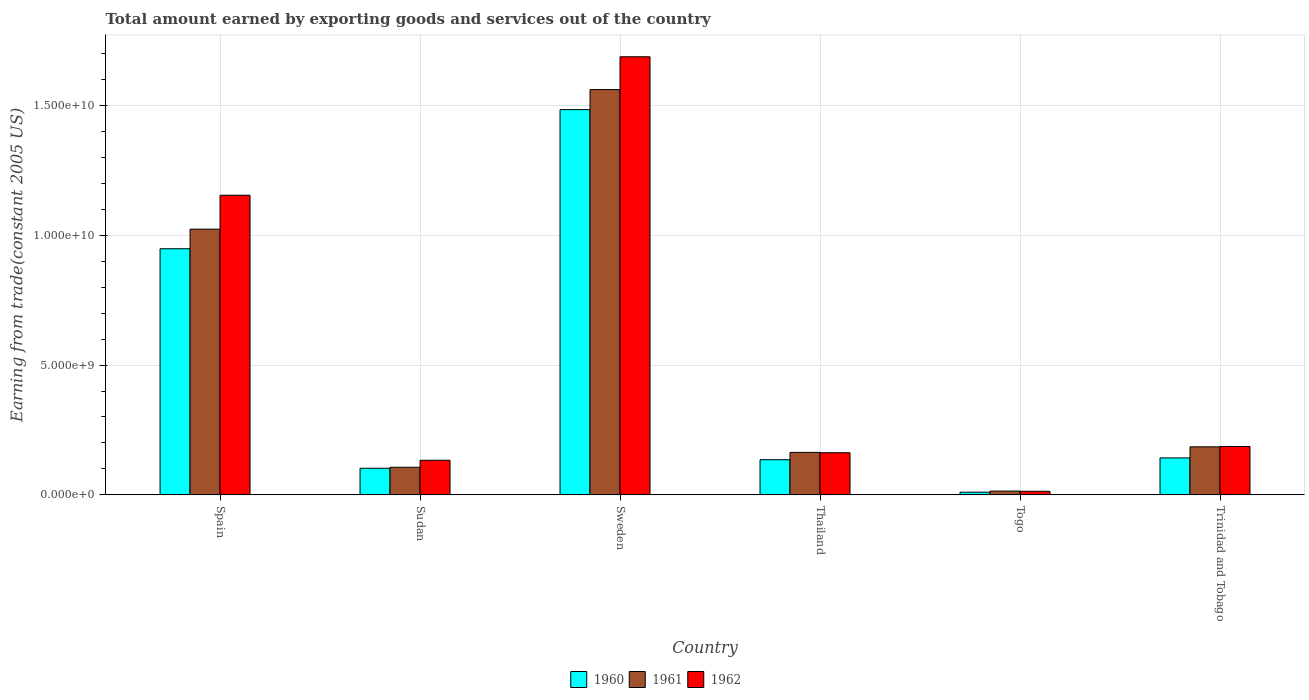How many groups of bars are there?
Your response must be concise. 6. How many bars are there on the 6th tick from the right?
Your answer should be very brief. 3. What is the label of the 5th group of bars from the left?
Provide a succinct answer. Togo. What is the total amount earned by exporting goods and services in 1960 in Sudan?
Offer a very short reply. 1.03e+09. Across all countries, what is the maximum total amount earned by exporting goods and services in 1960?
Your answer should be compact. 1.48e+1. Across all countries, what is the minimum total amount earned by exporting goods and services in 1962?
Your answer should be compact. 1.39e+08. In which country was the total amount earned by exporting goods and services in 1960 minimum?
Give a very brief answer. Togo. What is the total total amount earned by exporting goods and services in 1961 in the graph?
Your answer should be compact. 3.05e+1. What is the difference between the total amount earned by exporting goods and services in 1961 in Spain and that in Togo?
Give a very brief answer. 1.01e+1. What is the difference between the total amount earned by exporting goods and services in 1962 in Spain and the total amount earned by exporting goods and services in 1960 in Sweden?
Your answer should be very brief. -3.30e+09. What is the average total amount earned by exporting goods and services in 1961 per country?
Offer a terse response. 5.09e+09. What is the difference between the total amount earned by exporting goods and services of/in 1960 and total amount earned by exporting goods and services of/in 1961 in Trinidad and Tobago?
Ensure brevity in your answer.  -4.27e+08. What is the ratio of the total amount earned by exporting goods and services in 1962 in Sweden to that in Thailand?
Your answer should be very brief. 10.4. Is the total amount earned by exporting goods and services in 1962 in Togo less than that in Trinidad and Tobago?
Offer a terse response. Yes. What is the difference between the highest and the second highest total amount earned by exporting goods and services in 1962?
Your answer should be compact. -5.33e+09. What is the difference between the highest and the lowest total amount earned by exporting goods and services in 1960?
Ensure brevity in your answer.  1.47e+1. Is the sum of the total amount earned by exporting goods and services in 1962 in Sudan and Thailand greater than the maximum total amount earned by exporting goods and services in 1960 across all countries?
Your answer should be compact. No. What does the 1st bar from the left in Sweden represents?
Offer a terse response. 1960. What does the 1st bar from the right in Sudan represents?
Provide a succinct answer. 1962. Is it the case that in every country, the sum of the total amount earned by exporting goods and services in 1962 and total amount earned by exporting goods and services in 1961 is greater than the total amount earned by exporting goods and services in 1960?
Offer a very short reply. Yes. What is the difference between two consecutive major ticks on the Y-axis?
Keep it short and to the point. 5.00e+09. Does the graph contain any zero values?
Make the answer very short. No. Does the graph contain grids?
Keep it short and to the point. Yes. Where does the legend appear in the graph?
Your response must be concise. Bottom center. What is the title of the graph?
Your answer should be very brief. Total amount earned by exporting goods and services out of the country. What is the label or title of the Y-axis?
Offer a very short reply. Earning from trade(constant 2005 US). What is the Earning from trade(constant 2005 US) in 1960 in Spain?
Your answer should be compact. 9.48e+09. What is the Earning from trade(constant 2005 US) in 1961 in Spain?
Ensure brevity in your answer.  1.02e+1. What is the Earning from trade(constant 2005 US) in 1962 in Spain?
Give a very brief answer. 1.15e+1. What is the Earning from trade(constant 2005 US) in 1960 in Sudan?
Provide a short and direct response. 1.03e+09. What is the Earning from trade(constant 2005 US) in 1961 in Sudan?
Your response must be concise. 1.06e+09. What is the Earning from trade(constant 2005 US) in 1962 in Sudan?
Your answer should be very brief. 1.33e+09. What is the Earning from trade(constant 2005 US) of 1960 in Sweden?
Provide a succinct answer. 1.48e+1. What is the Earning from trade(constant 2005 US) of 1961 in Sweden?
Keep it short and to the point. 1.56e+1. What is the Earning from trade(constant 2005 US) in 1962 in Sweden?
Provide a short and direct response. 1.69e+1. What is the Earning from trade(constant 2005 US) in 1960 in Thailand?
Keep it short and to the point. 1.35e+09. What is the Earning from trade(constant 2005 US) in 1961 in Thailand?
Your answer should be compact. 1.64e+09. What is the Earning from trade(constant 2005 US) in 1962 in Thailand?
Provide a short and direct response. 1.62e+09. What is the Earning from trade(constant 2005 US) in 1960 in Togo?
Provide a succinct answer. 1.04e+08. What is the Earning from trade(constant 2005 US) in 1961 in Togo?
Provide a succinct answer. 1.46e+08. What is the Earning from trade(constant 2005 US) in 1962 in Togo?
Offer a very short reply. 1.39e+08. What is the Earning from trade(constant 2005 US) of 1960 in Trinidad and Tobago?
Give a very brief answer. 1.42e+09. What is the Earning from trade(constant 2005 US) of 1961 in Trinidad and Tobago?
Offer a terse response. 1.85e+09. What is the Earning from trade(constant 2005 US) of 1962 in Trinidad and Tobago?
Give a very brief answer. 1.86e+09. Across all countries, what is the maximum Earning from trade(constant 2005 US) of 1960?
Offer a very short reply. 1.48e+1. Across all countries, what is the maximum Earning from trade(constant 2005 US) in 1961?
Your response must be concise. 1.56e+1. Across all countries, what is the maximum Earning from trade(constant 2005 US) in 1962?
Your answer should be very brief. 1.69e+1. Across all countries, what is the minimum Earning from trade(constant 2005 US) of 1960?
Offer a terse response. 1.04e+08. Across all countries, what is the minimum Earning from trade(constant 2005 US) of 1961?
Offer a very short reply. 1.46e+08. Across all countries, what is the minimum Earning from trade(constant 2005 US) of 1962?
Provide a succinct answer. 1.39e+08. What is the total Earning from trade(constant 2005 US) in 1960 in the graph?
Offer a very short reply. 2.82e+1. What is the total Earning from trade(constant 2005 US) in 1961 in the graph?
Give a very brief answer. 3.05e+1. What is the total Earning from trade(constant 2005 US) in 1962 in the graph?
Give a very brief answer. 3.34e+1. What is the difference between the Earning from trade(constant 2005 US) of 1960 in Spain and that in Sudan?
Give a very brief answer. 8.45e+09. What is the difference between the Earning from trade(constant 2005 US) of 1961 in Spain and that in Sudan?
Keep it short and to the point. 9.17e+09. What is the difference between the Earning from trade(constant 2005 US) in 1962 in Spain and that in Sudan?
Your response must be concise. 1.02e+1. What is the difference between the Earning from trade(constant 2005 US) of 1960 in Spain and that in Sweden?
Your answer should be compact. -5.36e+09. What is the difference between the Earning from trade(constant 2005 US) of 1961 in Spain and that in Sweden?
Offer a terse response. -5.37e+09. What is the difference between the Earning from trade(constant 2005 US) of 1962 in Spain and that in Sweden?
Offer a very short reply. -5.33e+09. What is the difference between the Earning from trade(constant 2005 US) in 1960 in Spain and that in Thailand?
Make the answer very short. 8.12e+09. What is the difference between the Earning from trade(constant 2005 US) of 1961 in Spain and that in Thailand?
Ensure brevity in your answer.  8.59e+09. What is the difference between the Earning from trade(constant 2005 US) in 1962 in Spain and that in Thailand?
Make the answer very short. 9.92e+09. What is the difference between the Earning from trade(constant 2005 US) of 1960 in Spain and that in Togo?
Make the answer very short. 9.37e+09. What is the difference between the Earning from trade(constant 2005 US) of 1961 in Spain and that in Togo?
Make the answer very short. 1.01e+1. What is the difference between the Earning from trade(constant 2005 US) of 1962 in Spain and that in Togo?
Make the answer very short. 1.14e+1. What is the difference between the Earning from trade(constant 2005 US) of 1960 in Spain and that in Trinidad and Tobago?
Your response must be concise. 8.05e+09. What is the difference between the Earning from trade(constant 2005 US) in 1961 in Spain and that in Trinidad and Tobago?
Your answer should be very brief. 8.38e+09. What is the difference between the Earning from trade(constant 2005 US) of 1962 in Spain and that in Trinidad and Tobago?
Your answer should be compact. 9.67e+09. What is the difference between the Earning from trade(constant 2005 US) of 1960 in Sudan and that in Sweden?
Keep it short and to the point. -1.38e+1. What is the difference between the Earning from trade(constant 2005 US) in 1961 in Sudan and that in Sweden?
Offer a very short reply. -1.45e+1. What is the difference between the Earning from trade(constant 2005 US) of 1962 in Sudan and that in Sweden?
Give a very brief answer. -1.55e+1. What is the difference between the Earning from trade(constant 2005 US) of 1960 in Sudan and that in Thailand?
Make the answer very short. -3.29e+08. What is the difference between the Earning from trade(constant 2005 US) of 1961 in Sudan and that in Thailand?
Offer a terse response. -5.74e+08. What is the difference between the Earning from trade(constant 2005 US) in 1962 in Sudan and that in Thailand?
Your answer should be very brief. -2.89e+08. What is the difference between the Earning from trade(constant 2005 US) in 1960 in Sudan and that in Togo?
Keep it short and to the point. 9.22e+08. What is the difference between the Earning from trade(constant 2005 US) of 1961 in Sudan and that in Togo?
Your answer should be very brief. 9.17e+08. What is the difference between the Earning from trade(constant 2005 US) in 1962 in Sudan and that in Togo?
Your response must be concise. 1.19e+09. What is the difference between the Earning from trade(constant 2005 US) of 1960 in Sudan and that in Trinidad and Tobago?
Give a very brief answer. -3.98e+08. What is the difference between the Earning from trade(constant 2005 US) in 1961 in Sudan and that in Trinidad and Tobago?
Your answer should be compact. -7.87e+08. What is the difference between the Earning from trade(constant 2005 US) of 1962 in Sudan and that in Trinidad and Tobago?
Keep it short and to the point. -5.31e+08. What is the difference between the Earning from trade(constant 2005 US) of 1960 in Sweden and that in Thailand?
Provide a succinct answer. 1.35e+1. What is the difference between the Earning from trade(constant 2005 US) in 1961 in Sweden and that in Thailand?
Provide a short and direct response. 1.40e+1. What is the difference between the Earning from trade(constant 2005 US) in 1962 in Sweden and that in Thailand?
Ensure brevity in your answer.  1.52e+1. What is the difference between the Earning from trade(constant 2005 US) in 1960 in Sweden and that in Togo?
Give a very brief answer. 1.47e+1. What is the difference between the Earning from trade(constant 2005 US) of 1961 in Sweden and that in Togo?
Your answer should be compact. 1.55e+1. What is the difference between the Earning from trade(constant 2005 US) in 1962 in Sweden and that in Togo?
Offer a very short reply. 1.67e+1. What is the difference between the Earning from trade(constant 2005 US) of 1960 in Sweden and that in Trinidad and Tobago?
Offer a terse response. 1.34e+1. What is the difference between the Earning from trade(constant 2005 US) in 1961 in Sweden and that in Trinidad and Tobago?
Provide a succinct answer. 1.38e+1. What is the difference between the Earning from trade(constant 2005 US) in 1962 in Sweden and that in Trinidad and Tobago?
Offer a terse response. 1.50e+1. What is the difference between the Earning from trade(constant 2005 US) in 1960 in Thailand and that in Togo?
Your response must be concise. 1.25e+09. What is the difference between the Earning from trade(constant 2005 US) in 1961 in Thailand and that in Togo?
Give a very brief answer. 1.49e+09. What is the difference between the Earning from trade(constant 2005 US) of 1962 in Thailand and that in Togo?
Your answer should be compact. 1.48e+09. What is the difference between the Earning from trade(constant 2005 US) of 1960 in Thailand and that in Trinidad and Tobago?
Provide a succinct answer. -6.88e+07. What is the difference between the Earning from trade(constant 2005 US) in 1961 in Thailand and that in Trinidad and Tobago?
Offer a very short reply. -2.13e+08. What is the difference between the Earning from trade(constant 2005 US) in 1962 in Thailand and that in Trinidad and Tobago?
Provide a succinct answer. -2.41e+08. What is the difference between the Earning from trade(constant 2005 US) of 1960 in Togo and that in Trinidad and Tobago?
Ensure brevity in your answer.  -1.32e+09. What is the difference between the Earning from trade(constant 2005 US) of 1961 in Togo and that in Trinidad and Tobago?
Your answer should be very brief. -1.70e+09. What is the difference between the Earning from trade(constant 2005 US) in 1962 in Togo and that in Trinidad and Tobago?
Your answer should be compact. -1.73e+09. What is the difference between the Earning from trade(constant 2005 US) in 1960 in Spain and the Earning from trade(constant 2005 US) in 1961 in Sudan?
Keep it short and to the point. 8.41e+09. What is the difference between the Earning from trade(constant 2005 US) in 1960 in Spain and the Earning from trade(constant 2005 US) in 1962 in Sudan?
Ensure brevity in your answer.  8.14e+09. What is the difference between the Earning from trade(constant 2005 US) of 1961 in Spain and the Earning from trade(constant 2005 US) of 1962 in Sudan?
Make the answer very short. 8.90e+09. What is the difference between the Earning from trade(constant 2005 US) in 1960 in Spain and the Earning from trade(constant 2005 US) in 1961 in Sweden?
Your answer should be compact. -6.13e+09. What is the difference between the Earning from trade(constant 2005 US) of 1960 in Spain and the Earning from trade(constant 2005 US) of 1962 in Sweden?
Make the answer very short. -7.39e+09. What is the difference between the Earning from trade(constant 2005 US) of 1961 in Spain and the Earning from trade(constant 2005 US) of 1962 in Sweden?
Ensure brevity in your answer.  -6.64e+09. What is the difference between the Earning from trade(constant 2005 US) of 1960 in Spain and the Earning from trade(constant 2005 US) of 1961 in Thailand?
Ensure brevity in your answer.  7.84e+09. What is the difference between the Earning from trade(constant 2005 US) in 1960 in Spain and the Earning from trade(constant 2005 US) in 1962 in Thailand?
Provide a short and direct response. 7.86e+09. What is the difference between the Earning from trade(constant 2005 US) of 1961 in Spain and the Earning from trade(constant 2005 US) of 1962 in Thailand?
Give a very brief answer. 8.61e+09. What is the difference between the Earning from trade(constant 2005 US) of 1960 in Spain and the Earning from trade(constant 2005 US) of 1961 in Togo?
Provide a succinct answer. 9.33e+09. What is the difference between the Earning from trade(constant 2005 US) in 1960 in Spain and the Earning from trade(constant 2005 US) in 1962 in Togo?
Your answer should be compact. 9.34e+09. What is the difference between the Earning from trade(constant 2005 US) of 1961 in Spain and the Earning from trade(constant 2005 US) of 1962 in Togo?
Keep it short and to the point. 1.01e+1. What is the difference between the Earning from trade(constant 2005 US) of 1960 in Spain and the Earning from trade(constant 2005 US) of 1961 in Trinidad and Tobago?
Give a very brief answer. 7.63e+09. What is the difference between the Earning from trade(constant 2005 US) in 1960 in Spain and the Earning from trade(constant 2005 US) in 1962 in Trinidad and Tobago?
Make the answer very short. 7.61e+09. What is the difference between the Earning from trade(constant 2005 US) in 1961 in Spain and the Earning from trade(constant 2005 US) in 1962 in Trinidad and Tobago?
Make the answer very short. 8.37e+09. What is the difference between the Earning from trade(constant 2005 US) of 1960 in Sudan and the Earning from trade(constant 2005 US) of 1961 in Sweden?
Keep it short and to the point. -1.46e+1. What is the difference between the Earning from trade(constant 2005 US) in 1960 in Sudan and the Earning from trade(constant 2005 US) in 1962 in Sweden?
Provide a short and direct response. -1.58e+1. What is the difference between the Earning from trade(constant 2005 US) in 1961 in Sudan and the Earning from trade(constant 2005 US) in 1962 in Sweden?
Provide a succinct answer. -1.58e+1. What is the difference between the Earning from trade(constant 2005 US) in 1960 in Sudan and the Earning from trade(constant 2005 US) in 1961 in Thailand?
Provide a short and direct response. -6.12e+08. What is the difference between the Earning from trade(constant 2005 US) of 1960 in Sudan and the Earning from trade(constant 2005 US) of 1962 in Thailand?
Give a very brief answer. -5.97e+08. What is the difference between the Earning from trade(constant 2005 US) of 1961 in Sudan and the Earning from trade(constant 2005 US) of 1962 in Thailand?
Provide a succinct answer. -5.59e+08. What is the difference between the Earning from trade(constant 2005 US) in 1960 in Sudan and the Earning from trade(constant 2005 US) in 1961 in Togo?
Offer a terse response. 8.79e+08. What is the difference between the Earning from trade(constant 2005 US) in 1960 in Sudan and the Earning from trade(constant 2005 US) in 1962 in Togo?
Offer a very short reply. 8.86e+08. What is the difference between the Earning from trade(constant 2005 US) of 1961 in Sudan and the Earning from trade(constant 2005 US) of 1962 in Togo?
Your answer should be very brief. 9.25e+08. What is the difference between the Earning from trade(constant 2005 US) of 1960 in Sudan and the Earning from trade(constant 2005 US) of 1961 in Trinidad and Tobago?
Your answer should be very brief. -8.25e+08. What is the difference between the Earning from trade(constant 2005 US) of 1960 in Sudan and the Earning from trade(constant 2005 US) of 1962 in Trinidad and Tobago?
Make the answer very short. -8.39e+08. What is the difference between the Earning from trade(constant 2005 US) of 1961 in Sudan and the Earning from trade(constant 2005 US) of 1962 in Trinidad and Tobago?
Your answer should be very brief. -8.00e+08. What is the difference between the Earning from trade(constant 2005 US) in 1960 in Sweden and the Earning from trade(constant 2005 US) in 1961 in Thailand?
Offer a terse response. 1.32e+1. What is the difference between the Earning from trade(constant 2005 US) in 1960 in Sweden and the Earning from trade(constant 2005 US) in 1962 in Thailand?
Provide a short and direct response. 1.32e+1. What is the difference between the Earning from trade(constant 2005 US) in 1961 in Sweden and the Earning from trade(constant 2005 US) in 1962 in Thailand?
Provide a succinct answer. 1.40e+1. What is the difference between the Earning from trade(constant 2005 US) in 1960 in Sweden and the Earning from trade(constant 2005 US) in 1961 in Togo?
Ensure brevity in your answer.  1.47e+1. What is the difference between the Earning from trade(constant 2005 US) of 1960 in Sweden and the Earning from trade(constant 2005 US) of 1962 in Togo?
Your answer should be compact. 1.47e+1. What is the difference between the Earning from trade(constant 2005 US) of 1961 in Sweden and the Earning from trade(constant 2005 US) of 1962 in Togo?
Your answer should be compact. 1.55e+1. What is the difference between the Earning from trade(constant 2005 US) in 1960 in Sweden and the Earning from trade(constant 2005 US) in 1961 in Trinidad and Tobago?
Give a very brief answer. 1.30e+1. What is the difference between the Earning from trade(constant 2005 US) in 1960 in Sweden and the Earning from trade(constant 2005 US) in 1962 in Trinidad and Tobago?
Give a very brief answer. 1.30e+1. What is the difference between the Earning from trade(constant 2005 US) in 1961 in Sweden and the Earning from trade(constant 2005 US) in 1962 in Trinidad and Tobago?
Your answer should be very brief. 1.37e+1. What is the difference between the Earning from trade(constant 2005 US) in 1960 in Thailand and the Earning from trade(constant 2005 US) in 1961 in Togo?
Offer a terse response. 1.21e+09. What is the difference between the Earning from trade(constant 2005 US) in 1960 in Thailand and the Earning from trade(constant 2005 US) in 1962 in Togo?
Give a very brief answer. 1.22e+09. What is the difference between the Earning from trade(constant 2005 US) of 1961 in Thailand and the Earning from trade(constant 2005 US) of 1962 in Togo?
Make the answer very short. 1.50e+09. What is the difference between the Earning from trade(constant 2005 US) in 1960 in Thailand and the Earning from trade(constant 2005 US) in 1961 in Trinidad and Tobago?
Ensure brevity in your answer.  -4.96e+08. What is the difference between the Earning from trade(constant 2005 US) of 1960 in Thailand and the Earning from trade(constant 2005 US) of 1962 in Trinidad and Tobago?
Provide a short and direct response. -5.09e+08. What is the difference between the Earning from trade(constant 2005 US) of 1961 in Thailand and the Earning from trade(constant 2005 US) of 1962 in Trinidad and Tobago?
Ensure brevity in your answer.  -2.26e+08. What is the difference between the Earning from trade(constant 2005 US) in 1960 in Togo and the Earning from trade(constant 2005 US) in 1961 in Trinidad and Tobago?
Offer a terse response. -1.75e+09. What is the difference between the Earning from trade(constant 2005 US) in 1960 in Togo and the Earning from trade(constant 2005 US) in 1962 in Trinidad and Tobago?
Provide a short and direct response. -1.76e+09. What is the difference between the Earning from trade(constant 2005 US) of 1961 in Togo and the Earning from trade(constant 2005 US) of 1962 in Trinidad and Tobago?
Your answer should be compact. -1.72e+09. What is the average Earning from trade(constant 2005 US) of 1960 per country?
Your answer should be compact. 4.70e+09. What is the average Earning from trade(constant 2005 US) in 1961 per country?
Your answer should be very brief. 5.09e+09. What is the average Earning from trade(constant 2005 US) in 1962 per country?
Ensure brevity in your answer.  5.56e+09. What is the difference between the Earning from trade(constant 2005 US) in 1960 and Earning from trade(constant 2005 US) in 1961 in Spain?
Provide a short and direct response. -7.54e+08. What is the difference between the Earning from trade(constant 2005 US) in 1960 and Earning from trade(constant 2005 US) in 1962 in Spain?
Provide a short and direct response. -2.06e+09. What is the difference between the Earning from trade(constant 2005 US) of 1961 and Earning from trade(constant 2005 US) of 1962 in Spain?
Provide a short and direct response. -1.31e+09. What is the difference between the Earning from trade(constant 2005 US) of 1960 and Earning from trade(constant 2005 US) of 1961 in Sudan?
Give a very brief answer. -3.85e+07. What is the difference between the Earning from trade(constant 2005 US) in 1960 and Earning from trade(constant 2005 US) in 1962 in Sudan?
Your answer should be compact. -3.08e+08. What is the difference between the Earning from trade(constant 2005 US) in 1961 and Earning from trade(constant 2005 US) in 1962 in Sudan?
Offer a very short reply. -2.69e+08. What is the difference between the Earning from trade(constant 2005 US) of 1960 and Earning from trade(constant 2005 US) of 1961 in Sweden?
Your response must be concise. -7.72e+08. What is the difference between the Earning from trade(constant 2005 US) in 1960 and Earning from trade(constant 2005 US) in 1962 in Sweden?
Your answer should be compact. -2.03e+09. What is the difference between the Earning from trade(constant 2005 US) of 1961 and Earning from trade(constant 2005 US) of 1962 in Sweden?
Your answer should be compact. -1.26e+09. What is the difference between the Earning from trade(constant 2005 US) of 1960 and Earning from trade(constant 2005 US) of 1961 in Thailand?
Ensure brevity in your answer.  -2.83e+08. What is the difference between the Earning from trade(constant 2005 US) in 1960 and Earning from trade(constant 2005 US) in 1962 in Thailand?
Provide a succinct answer. -2.68e+08. What is the difference between the Earning from trade(constant 2005 US) in 1961 and Earning from trade(constant 2005 US) in 1962 in Thailand?
Provide a short and direct response. 1.49e+07. What is the difference between the Earning from trade(constant 2005 US) in 1960 and Earning from trade(constant 2005 US) in 1961 in Togo?
Your response must be concise. -4.26e+07. What is the difference between the Earning from trade(constant 2005 US) of 1960 and Earning from trade(constant 2005 US) of 1962 in Togo?
Give a very brief answer. -3.51e+07. What is the difference between the Earning from trade(constant 2005 US) in 1961 and Earning from trade(constant 2005 US) in 1962 in Togo?
Your response must be concise. 7.52e+06. What is the difference between the Earning from trade(constant 2005 US) of 1960 and Earning from trade(constant 2005 US) of 1961 in Trinidad and Tobago?
Offer a very short reply. -4.27e+08. What is the difference between the Earning from trade(constant 2005 US) of 1960 and Earning from trade(constant 2005 US) of 1962 in Trinidad and Tobago?
Provide a succinct answer. -4.40e+08. What is the difference between the Earning from trade(constant 2005 US) of 1961 and Earning from trade(constant 2005 US) of 1962 in Trinidad and Tobago?
Make the answer very short. -1.34e+07. What is the ratio of the Earning from trade(constant 2005 US) in 1960 in Spain to that in Sudan?
Ensure brevity in your answer.  9.24. What is the ratio of the Earning from trade(constant 2005 US) in 1961 in Spain to that in Sudan?
Ensure brevity in your answer.  9.62. What is the ratio of the Earning from trade(constant 2005 US) in 1962 in Spain to that in Sudan?
Make the answer very short. 8.65. What is the ratio of the Earning from trade(constant 2005 US) of 1960 in Spain to that in Sweden?
Provide a succinct answer. 0.64. What is the ratio of the Earning from trade(constant 2005 US) in 1961 in Spain to that in Sweden?
Make the answer very short. 0.66. What is the ratio of the Earning from trade(constant 2005 US) in 1962 in Spain to that in Sweden?
Offer a terse response. 0.68. What is the ratio of the Earning from trade(constant 2005 US) of 1960 in Spain to that in Thailand?
Your answer should be very brief. 7. What is the ratio of the Earning from trade(constant 2005 US) in 1961 in Spain to that in Thailand?
Your response must be concise. 6.25. What is the ratio of the Earning from trade(constant 2005 US) in 1962 in Spain to that in Thailand?
Your response must be concise. 7.11. What is the ratio of the Earning from trade(constant 2005 US) of 1960 in Spain to that in Togo?
Give a very brief answer. 91.31. What is the ratio of the Earning from trade(constant 2005 US) of 1961 in Spain to that in Togo?
Make the answer very short. 69.88. What is the ratio of the Earning from trade(constant 2005 US) in 1962 in Spain to that in Togo?
Offer a terse response. 83.07. What is the ratio of the Earning from trade(constant 2005 US) in 1960 in Spain to that in Trinidad and Tobago?
Provide a short and direct response. 6.66. What is the ratio of the Earning from trade(constant 2005 US) of 1961 in Spain to that in Trinidad and Tobago?
Your answer should be very brief. 5.53. What is the ratio of the Earning from trade(constant 2005 US) in 1962 in Spain to that in Trinidad and Tobago?
Your answer should be very brief. 6.19. What is the ratio of the Earning from trade(constant 2005 US) in 1960 in Sudan to that in Sweden?
Give a very brief answer. 0.07. What is the ratio of the Earning from trade(constant 2005 US) in 1961 in Sudan to that in Sweden?
Make the answer very short. 0.07. What is the ratio of the Earning from trade(constant 2005 US) in 1962 in Sudan to that in Sweden?
Make the answer very short. 0.08. What is the ratio of the Earning from trade(constant 2005 US) of 1960 in Sudan to that in Thailand?
Your response must be concise. 0.76. What is the ratio of the Earning from trade(constant 2005 US) of 1961 in Sudan to that in Thailand?
Your answer should be very brief. 0.65. What is the ratio of the Earning from trade(constant 2005 US) in 1962 in Sudan to that in Thailand?
Keep it short and to the point. 0.82. What is the ratio of the Earning from trade(constant 2005 US) of 1960 in Sudan to that in Togo?
Offer a terse response. 9.88. What is the ratio of the Earning from trade(constant 2005 US) of 1961 in Sudan to that in Togo?
Keep it short and to the point. 7.27. What is the ratio of the Earning from trade(constant 2005 US) in 1962 in Sudan to that in Togo?
Your answer should be compact. 9.6. What is the ratio of the Earning from trade(constant 2005 US) of 1960 in Sudan to that in Trinidad and Tobago?
Provide a succinct answer. 0.72. What is the ratio of the Earning from trade(constant 2005 US) of 1961 in Sudan to that in Trinidad and Tobago?
Give a very brief answer. 0.57. What is the ratio of the Earning from trade(constant 2005 US) of 1962 in Sudan to that in Trinidad and Tobago?
Your response must be concise. 0.72. What is the ratio of the Earning from trade(constant 2005 US) in 1960 in Sweden to that in Thailand?
Offer a terse response. 10.95. What is the ratio of the Earning from trade(constant 2005 US) of 1961 in Sweden to that in Thailand?
Your answer should be very brief. 9.53. What is the ratio of the Earning from trade(constant 2005 US) of 1962 in Sweden to that in Thailand?
Keep it short and to the point. 10.4. What is the ratio of the Earning from trade(constant 2005 US) of 1960 in Sweden to that in Togo?
Offer a terse response. 142.92. What is the ratio of the Earning from trade(constant 2005 US) in 1961 in Sweden to that in Togo?
Give a very brief answer. 106.59. What is the ratio of the Earning from trade(constant 2005 US) in 1962 in Sweden to that in Togo?
Your answer should be very brief. 121.45. What is the ratio of the Earning from trade(constant 2005 US) in 1960 in Sweden to that in Trinidad and Tobago?
Ensure brevity in your answer.  10.42. What is the ratio of the Earning from trade(constant 2005 US) of 1961 in Sweden to that in Trinidad and Tobago?
Your answer should be very brief. 8.43. What is the ratio of the Earning from trade(constant 2005 US) in 1962 in Sweden to that in Trinidad and Tobago?
Give a very brief answer. 9.05. What is the ratio of the Earning from trade(constant 2005 US) in 1960 in Thailand to that in Togo?
Your answer should be compact. 13.05. What is the ratio of the Earning from trade(constant 2005 US) of 1961 in Thailand to that in Togo?
Give a very brief answer. 11.18. What is the ratio of the Earning from trade(constant 2005 US) of 1962 in Thailand to that in Togo?
Keep it short and to the point. 11.68. What is the ratio of the Earning from trade(constant 2005 US) of 1960 in Thailand to that in Trinidad and Tobago?
Provide a short and direct response. 0.95. What is the ratio of the Earning from trade(constant 2005 US) of 1961 in Thailand to that in Trinidad and Tobago?
Provide a short and direct response. 0.88. What is the ratio of the Earning from trade(constant 2005 US) in 1962 in Thailand to that in Trinidad and Tobago?
Give a very brief answer. 0.87. What is the ratio of the Earning from trade(constant 2005 US) of 1960 in Togo to that in Trinidad and Tobago?
Make the answer very short. 0.07. What is the ratio of the Earning from trade(constant 2005 US) in 1961 in Togo to that in Trinidad and Tobago?
Provide a short and direct response. 0.08. What is the ratio of the Earning from trade(constant 2005 US) in 1962 in Togo to that in Trinidad and Tobago?
Offer a terse response. 0.07. What is the difference between the highest and the second highest Earning from trade(constant 2005 US) of 1960?
Your response must be concise. 5.36e+09. What is the difference between the highest and the second highest Earning from trade(constant 2005 US) of 1961?
Provide a short and direct response. 5.37e+09. What is the difference between the highest and the second highest Earning from trade(constant 2005 US) in 1962?
Your response must be concise. 5.33e+09. What is the difference between the highest and the lowest Earning from trade(constant 2005 US) of 1960?
Make the answer very short. 1.47e+1. What is the difference between the highest and the lowest Earning from trade(constant 2005 US) in 1961?
Provide a short and direct response. 1.55e+1. What is the difference between the highest and the lowest Earning from trade(constant 2005 US) in 1962?
Make the answer very short. 1.67e+1. 